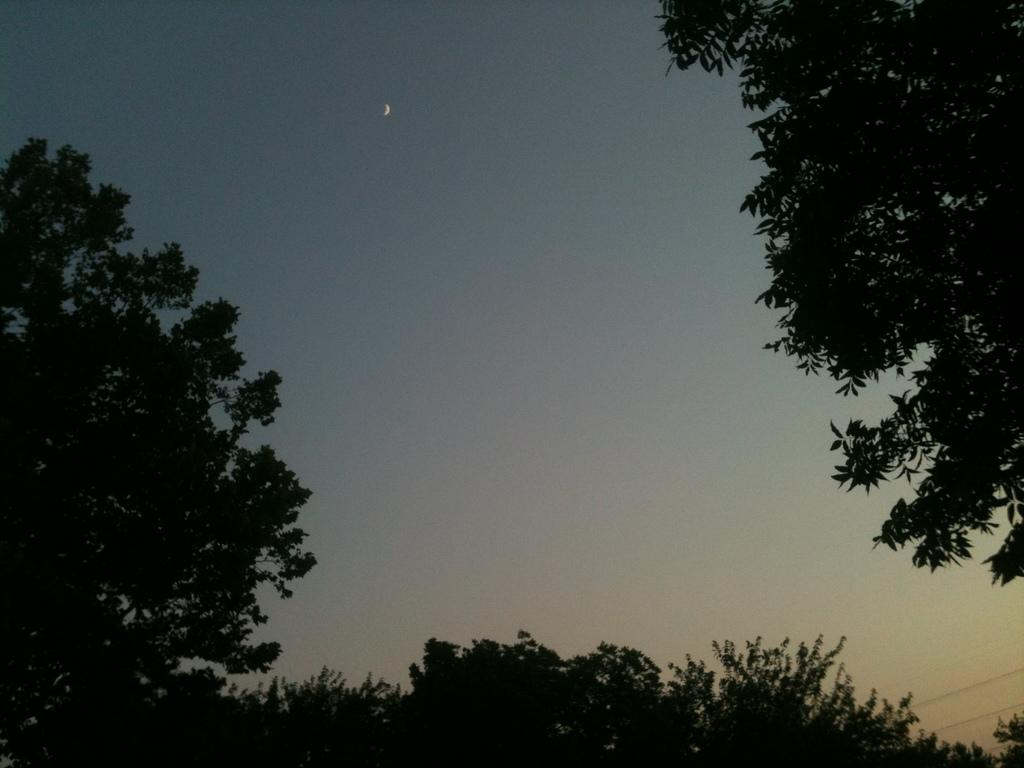What type of vegetation can be seen in the image? There are trees in the image. What part of the natural environment is visible in the image? The sky is visible in the image. What type of rule can be seen governing the behavior of the trees in the image? There is no rule governing the behavior of the trees in the image, as trees are natural objects and not subject to rules. What type of net is visible in the image? There is no net present in the image. 